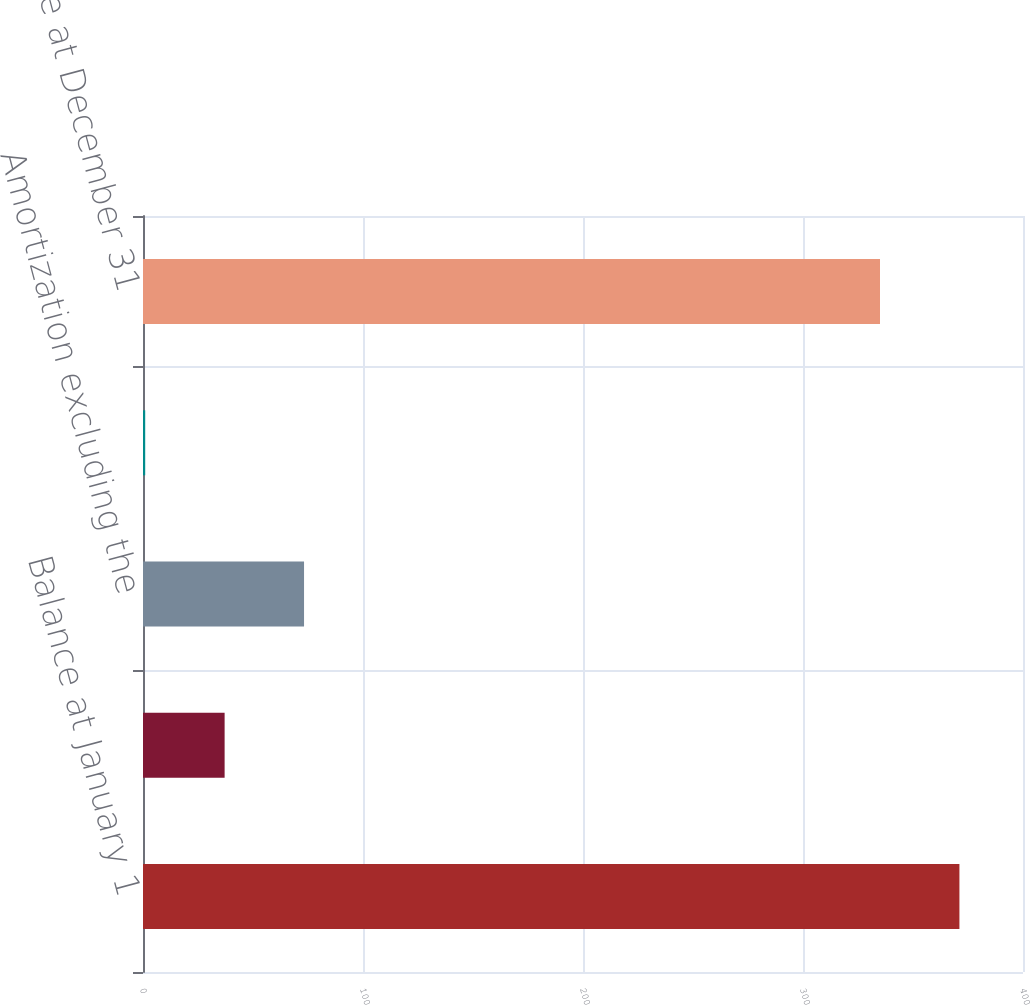Convert chart. <chart><loc_0><loc_0><loc_500><loc_500><bar_chart><fcel>Balance at January 1<fcel>Capitalization of sales<fcel>Amortization excluding the<fcel>Amortization impact of<fcel>Balance at December 31<nl><fcel>371.1<fcel>37.1<fcel>73.2<fcel>1<fcel>335<nl></chart> 